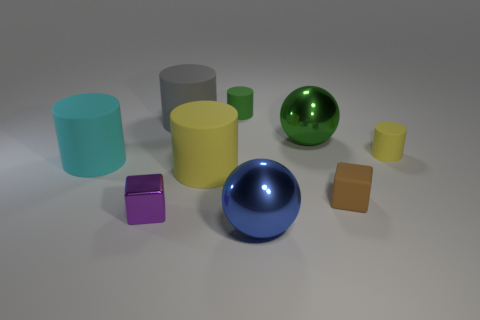Subtract all gray cylinders. How many cylinders are left? 4 Subtract all tiny green cylinders. How many cylinders are left? 4 Subtract all brown cylinders. Subtract all brown cubes. How many cylinders are left? 5 Subtract all spheres. How many objects are left? 7 Subtract 0 blue cubes. How many objects are left? 9 Subtract all large purple cubes. Subtract all cylinders. How many objects are left? 4 Add 4 large gray cylinders. How many large gray cylinders are left? 5 Add 5 brown things. How many brown things exist? 6 